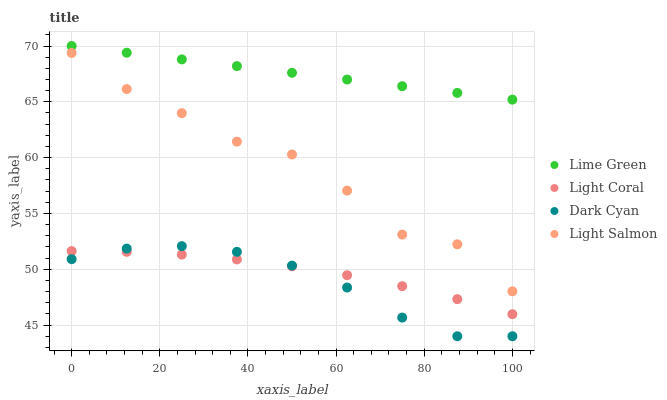Does Dark Cyan have the minimum area under the curve?
Answer yes or no. Yes. Does Lime Green have the maximum area under the curve?
Answer yes or no. Yes. Does Light Salmon have the minimum area under the curve?
Answer yes or no. No. Does Light Salmon have the maximum area under the curve?
Answer yes or no. No. Is Lime Green the smoothest?
Answer yes or no. Yes. Is Light Salmon the roughest?
Answer yes or no. Yes. Is Dark Cyan the smoothest?
Answer yes or no. No. Is Dark Cyan the roughest?
Answer yes or no. No. Does Dark Cyan have the lowest value?
Answer yes or no. Yes. Does Light Salmon have the lowest value?
Answer yes or no. No. Does Lime Green have the highest value?
Answer yes or no. Yes. Does Dark Cyan have the highest value?
Answer yes or no. No. Is Dark Cyan less than Lime Green?
Answer yes or no. Yes. Is Lime Green greater than Dark Cyan?
Answer yes or no. Yes. Does Light Coral intersect Dark Cyan?
Answer yes or no. Yes. Is Light Coral less than Dark Cyan?
Answer yes or no. No. Is Light Coral greater than Dark Cyan?
Answer yes or no. No. Does Dark Cyan intersect Lime Green?
Answer yes or no. No. 